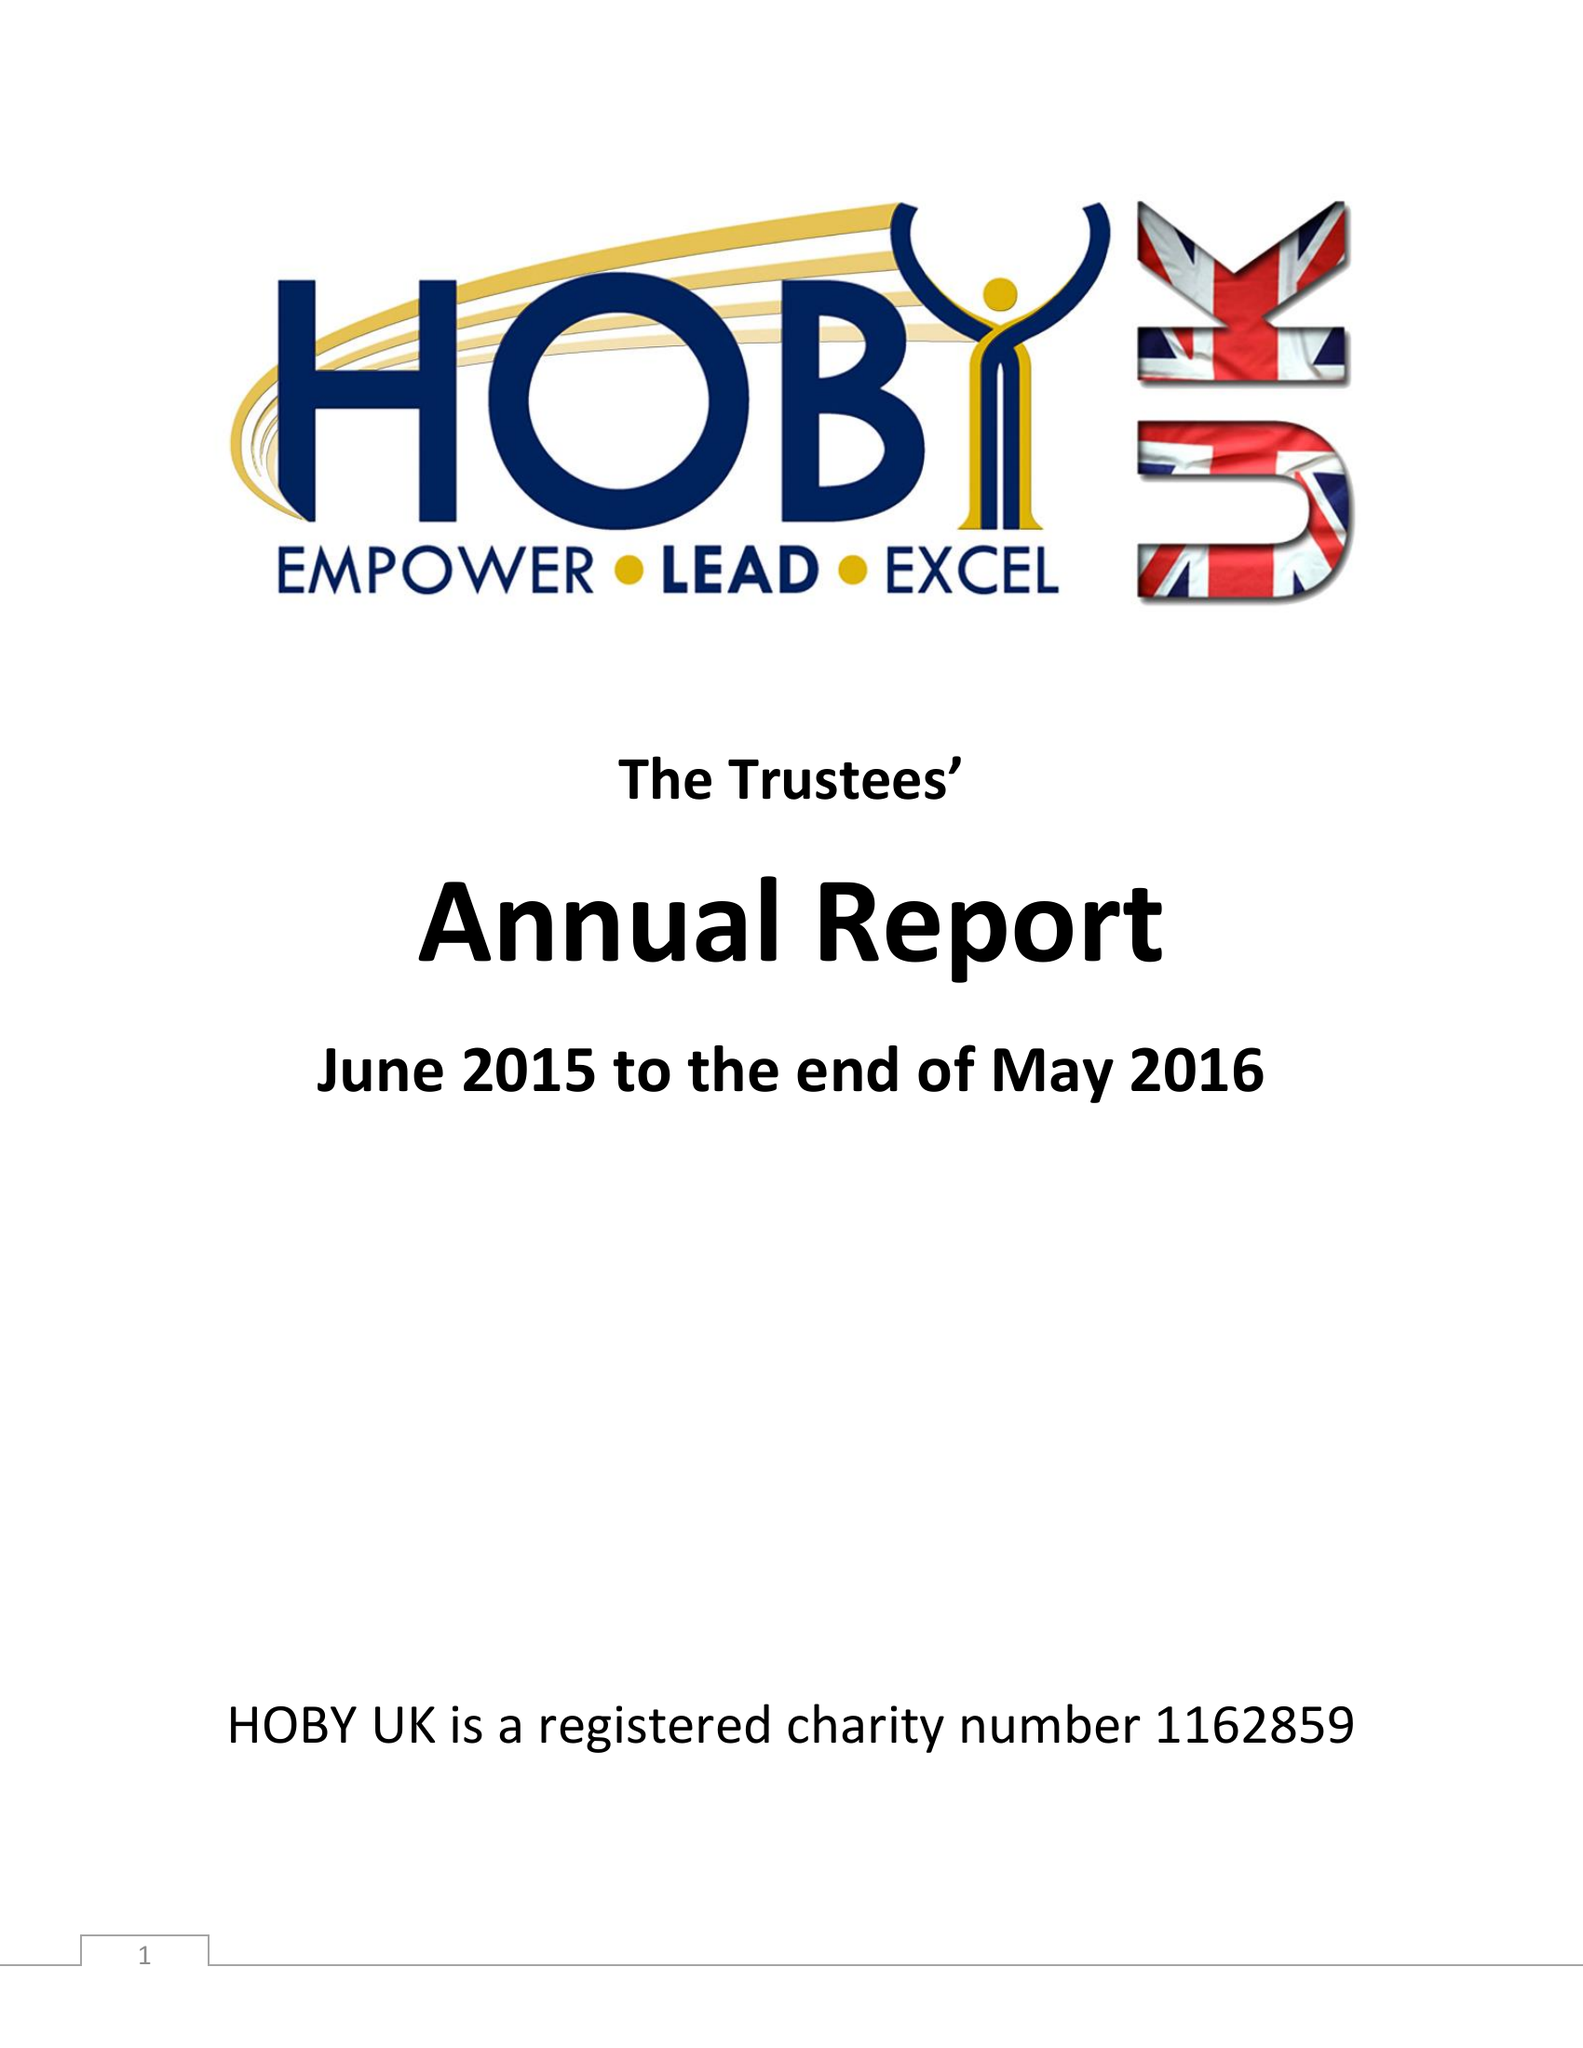What is the value for the charity_name?
Answer the question using a single word or phrase. Hoby Uk 